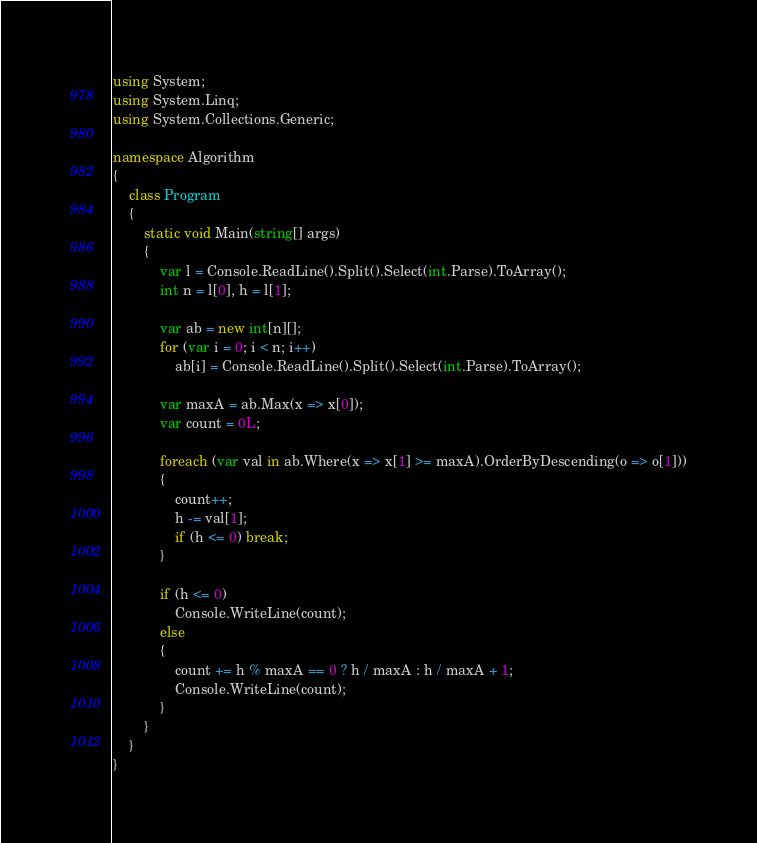<code> <loc_0><loc_0><loc_500><loc_500><_C#_>using System;
using System.Linq;
using System.Collections.Generic;

namespace Algorithm
{
    class Program
    {
        static void Main(string[] args)
        {
            var l = Console.ReadLine().Split().Select(int.Parse).ToArray();
            int n = l[0], h = l[1];

            var ab = new int[n][];
            for (var i = 0; i < n; i++)
                ab[i] = Console.ReadLine().Split().Select(int.Parse).ToArray();

            var maxA = ab.Max(x => x[0]);
            var count = 0L;

            foreach (var val in ab.Where(x => x[1] >= maxA).OrderByDescending(o => o[1]))
            {
                count++;
                h -= val[1];
                if (h <= 0) break;
            }

            if (h <= 0)
                Console.WriteLine(count);
            else
            {
                count += h % maxA == 0 ? h / maxA : h / maxA + 1;
                Console.WriteLine(count);
            }
        }
    }
}
</code> 